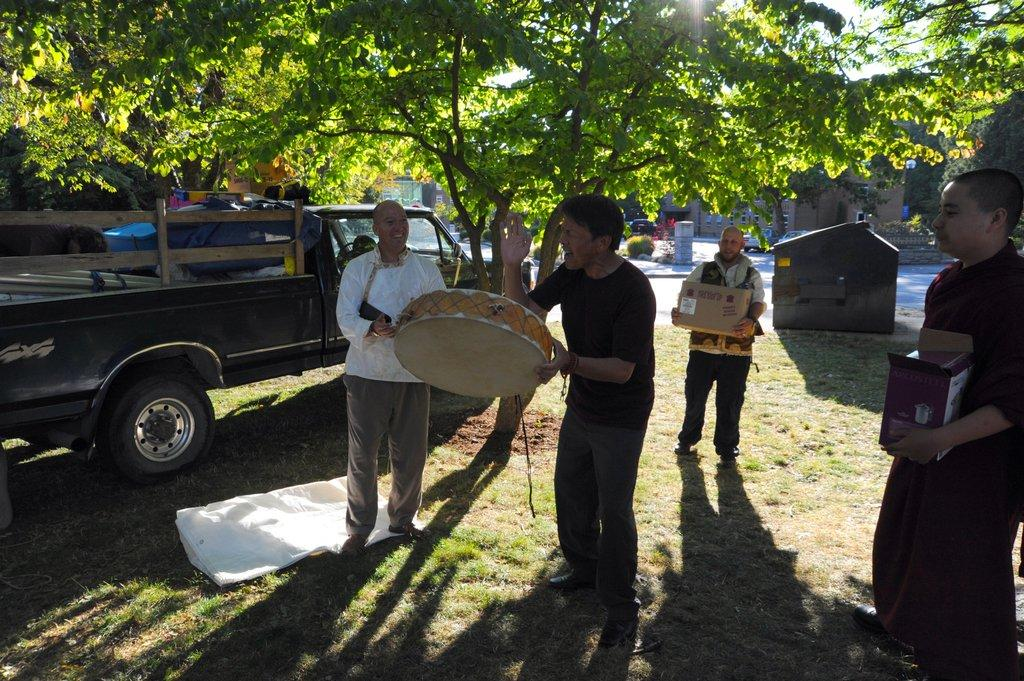How many people are in the image? There is a group of people in the image. What are the people doing in the image? The people are standing on the ground. What are the people holding in their hands? The people are holding objects in their hands. What type of vehicle is in the image? There is a truck in the image. What type of plant is in the image? There is a tree in the image. How many cats are sitting on the truck in the image? There are no cats present in the image; it only features a group of people, a truck, and a tree. 